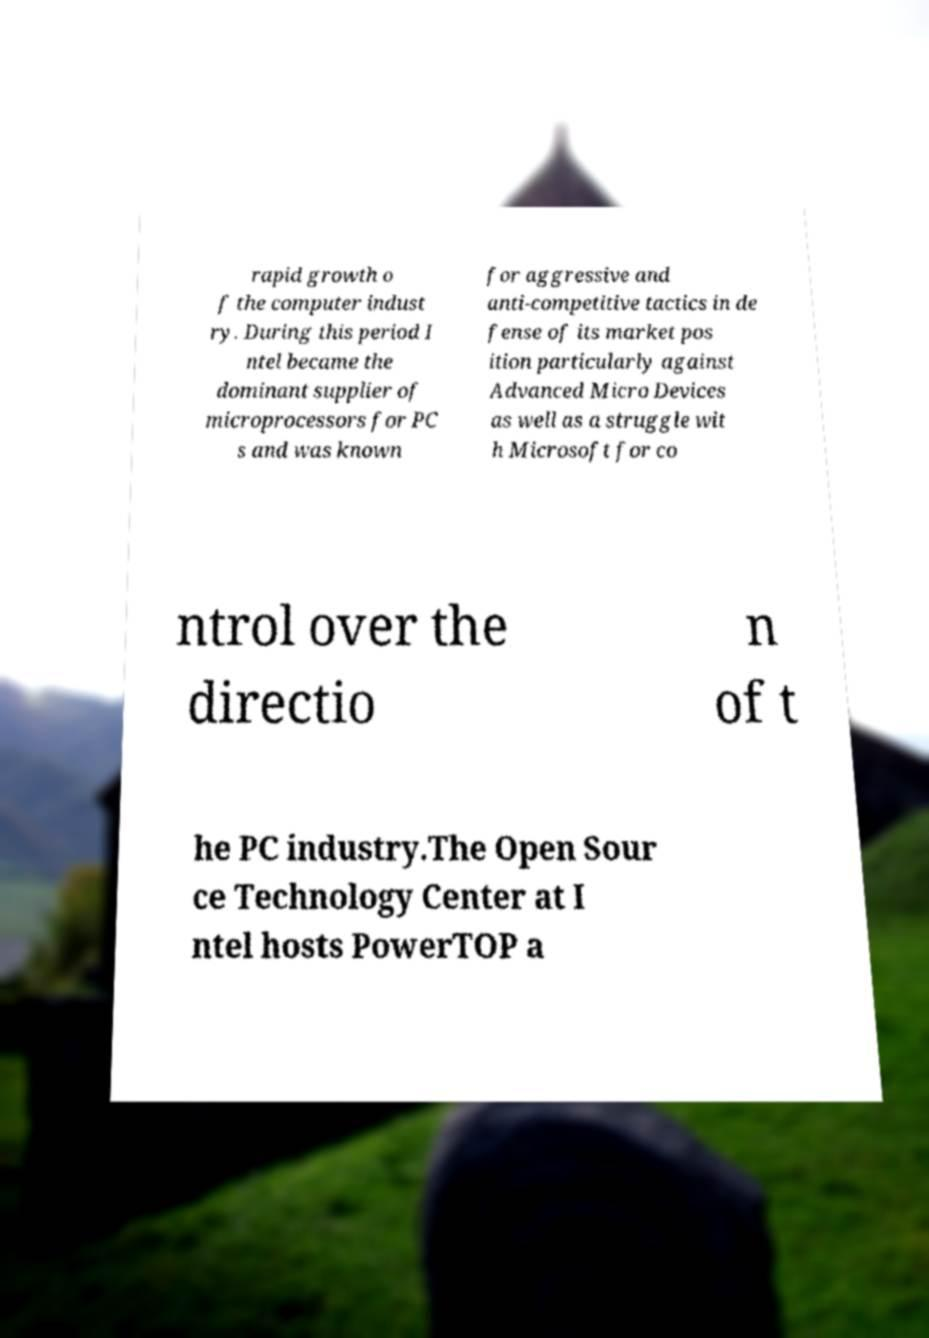Could you assist in decoding the text presented in this image and type it out clearly? rapid growth o f the computer indust ry. During this period I ntel became the dominant supplier of microprocessors for PC s and was known for aggressive and anti-competitive tactics in de fense of its market pos ition particularly against Advanced Micro Devices as well as a struggle wit h Microsoft for co ntrol over the directio n of t he PC industry.The Open Sour ce Technology Center at I ntel hosts PowerTOP a 